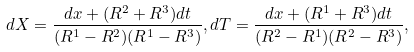Convert formula to latex. <formula><loc_0><loc_0><loc_500><loc_500>d X = \frac { d x + ( R ^ { 2 } + R ^ { 3 } ) d t } { ( R ^ { 1 } - R ^ { 2 } ) ( R ^ { 1 } - R ^ { 3 } ) } , d T = \frac { d x + ( R ^ { 1 } + R ^ { 3 } ) d t } { ( R ^ { 2 } - R ^ { 1 } ) ( R ^ { 2 } - R ^ { 3 } ) } ,</formula> 